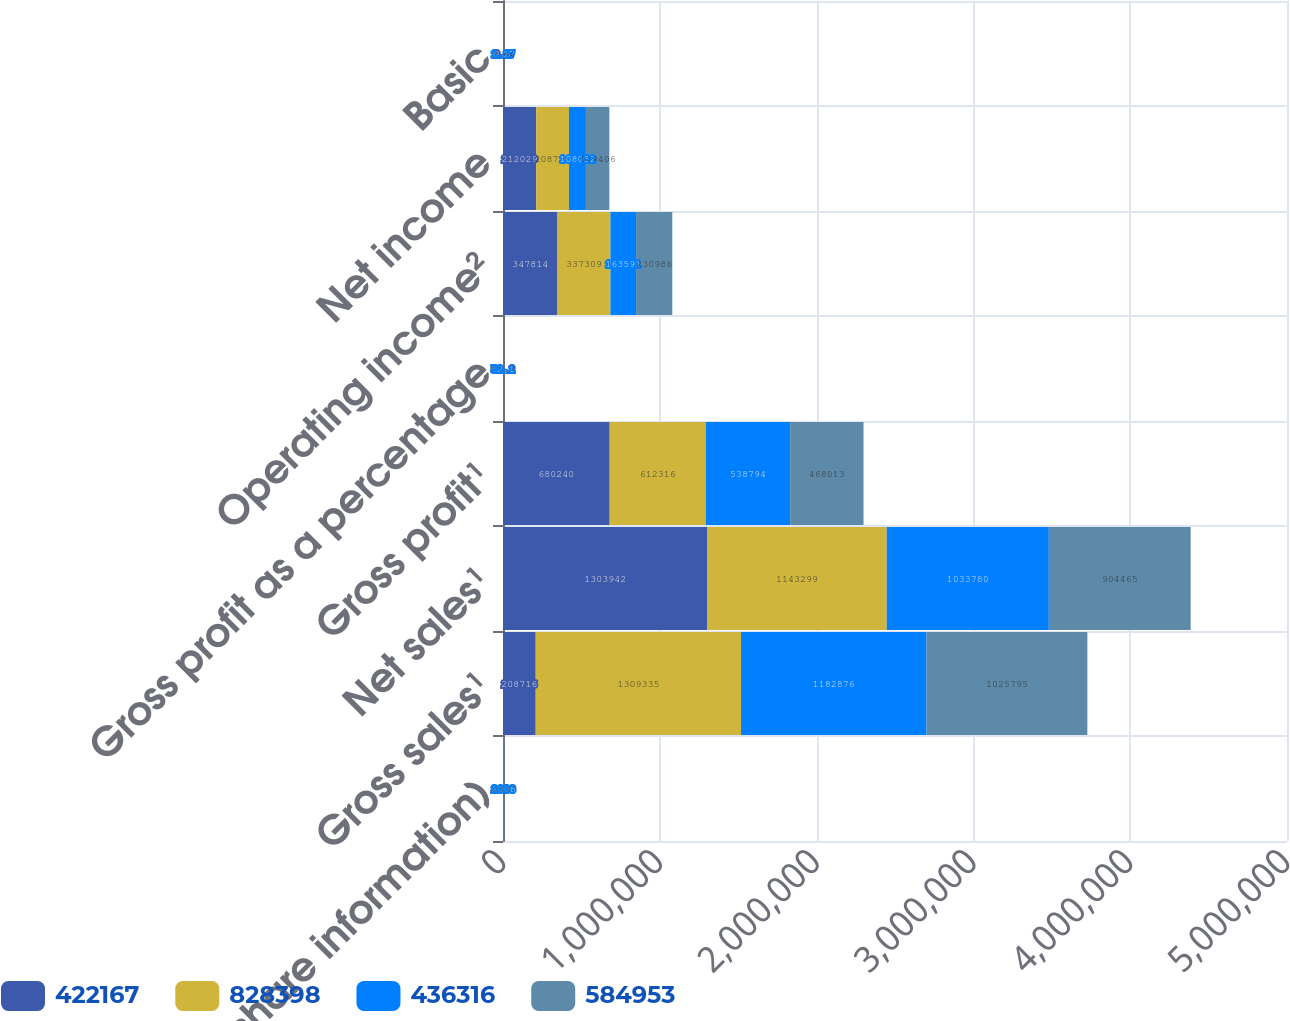Convert chart to OTSL. <chart><loc_0><loc_0><loc_500><loc_500><stacked_bar_chart><ecel><fcel>per share information)<fcel>Gross sales¹<fcel>Net sales¹<fcel>Gross profit¹<fcel>Gross profit as a percentage<fcel>Operating income²<fcel>Net income<fcel>Basic<nl><fcel>422167<fcel>2010<fcel>208716<fcel>1.30394e+06<fcel>680240<fcel>52.2<fcel>347814<fcel>212029<fcel>2.4<nl><fcel>828398<fcel>2009<fcel>1.30934e+06<fcel>1.1433e+06<fcel>612316<fcel>53.6<fcel>337309<fcel>208716<fcel>2.32<nl><fcel>436316<fcel>2008<fcel>1.18288e+06<fcel>1.03378e+06<fcel>538794<fcel>52.1<fcel>163591<fcel>108032<fcel>1.17<nl><fcel>584953<fcel>2007<fcel>1.0258e+06<fcel>904465<fcel>468013<fcel>51.7<fcel>230986<fcel>149406<fcel>1.64<nl></chart> 